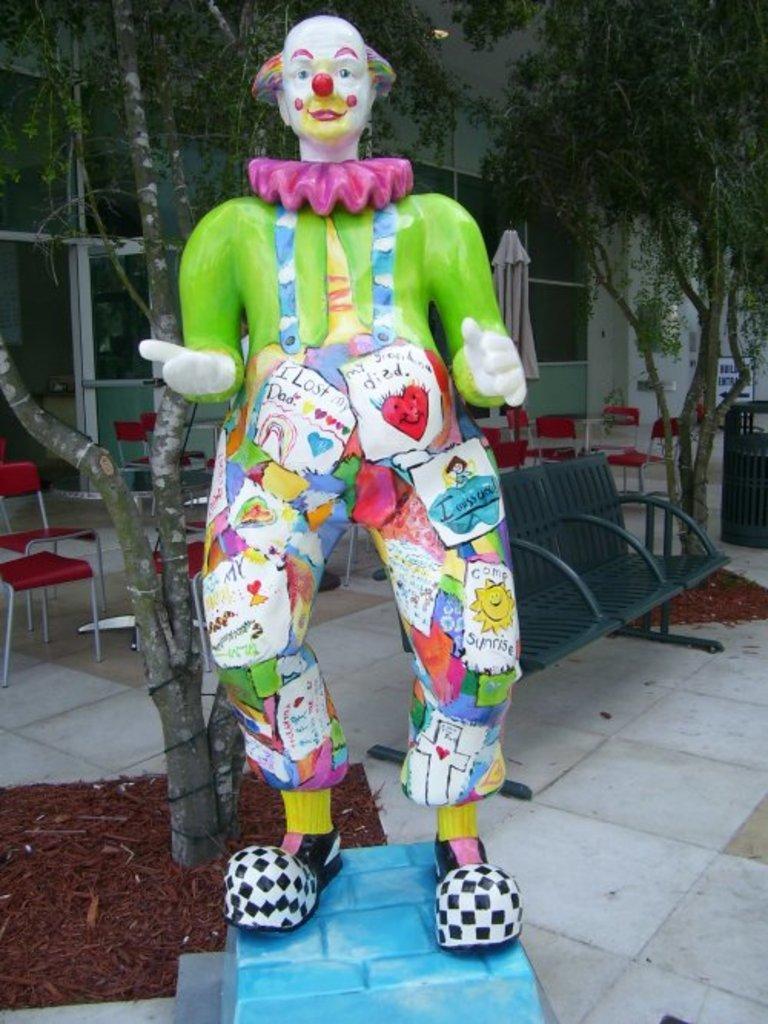Can you describe this image briefly? In this image we can see a sculpture, behind that there are some trees, chairs and a building. 